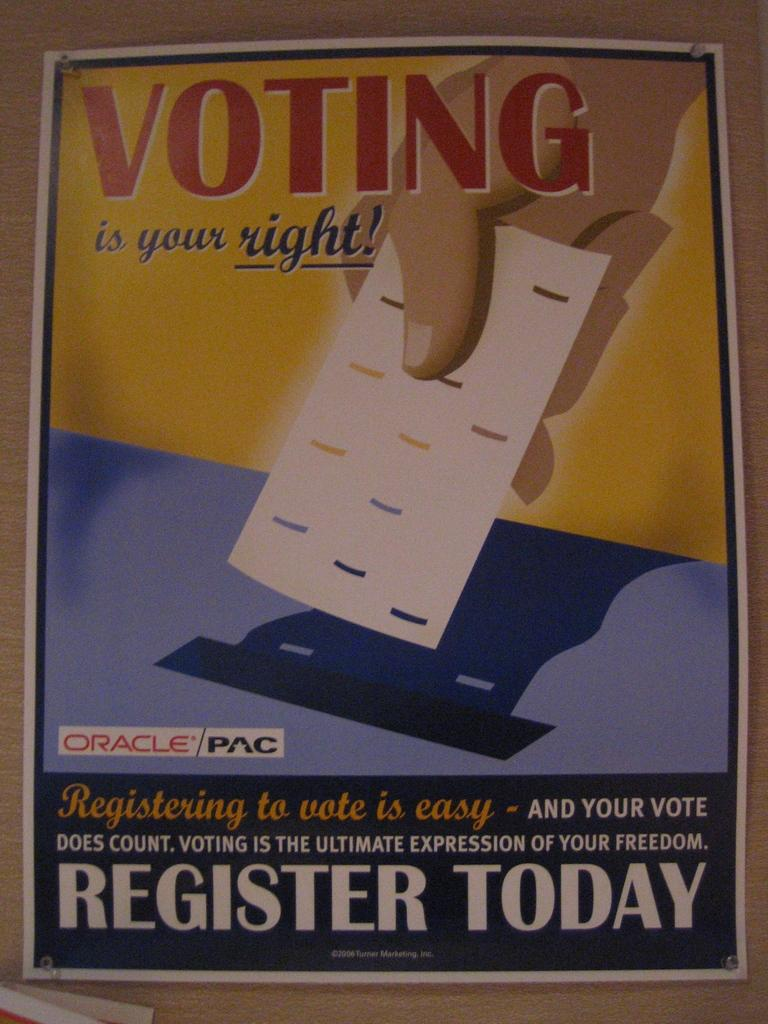Provide a one-sentence caption for the provided image. a poster for Voting is your Right sponsored by Oracle/PAC. 